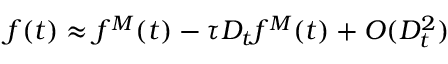Convert formula to latex. <formula><loc_0><loc_0><loc_500><loc_500>f ( t ) \approx f ^ { M } ( t ) - \tau D _ { t } f ^ { M } ( t ) + O ( D _ { t } ^ { 2 } )</formula> 